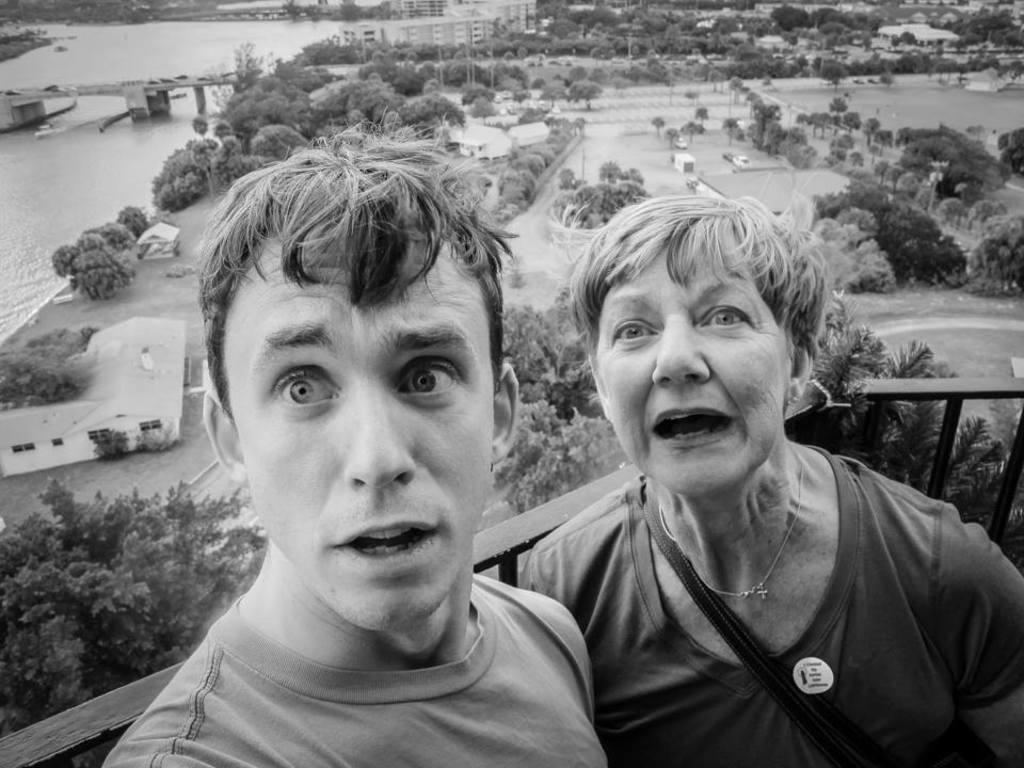Can you describe this image briefly? This is a black and white image, where there is a man and a woman with opened mouth. In the background, there is a railing, trees, water, bridge and few poles. 